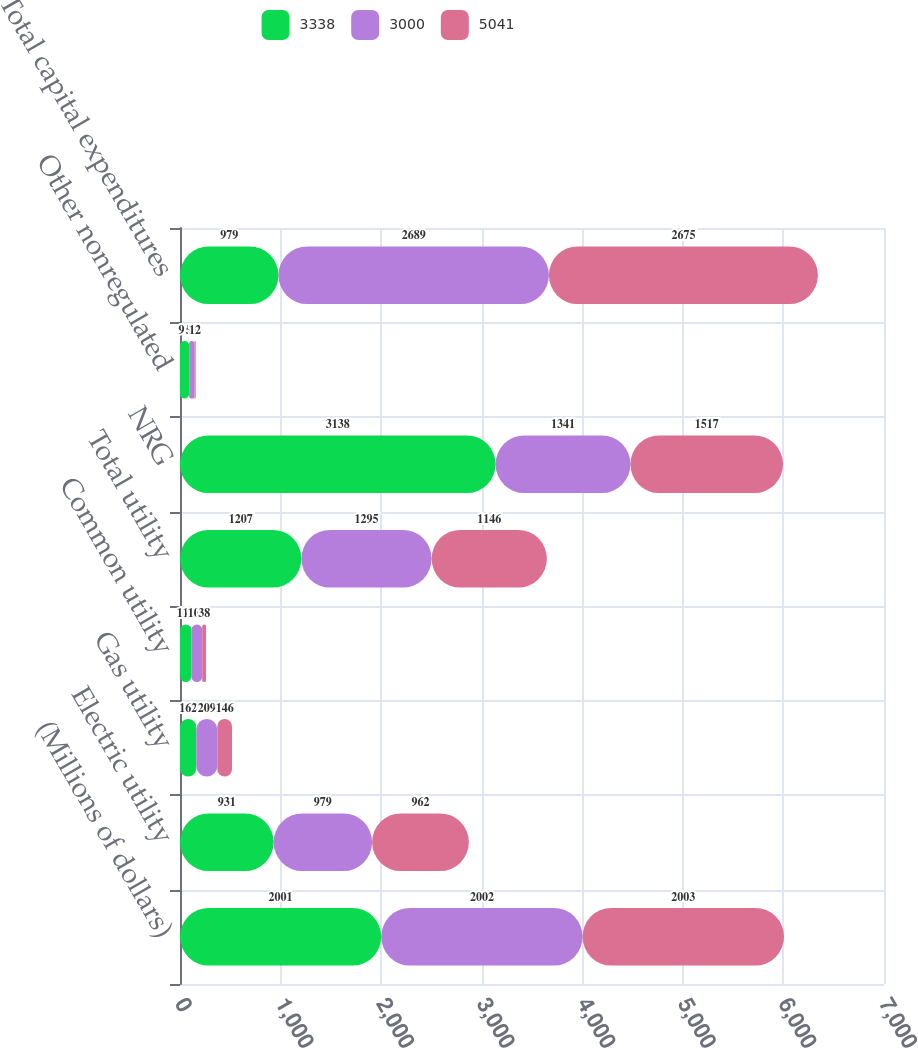Convert chart to OTSL. <chart><loc_0><loc_0><loc_500><loc_500><stacked_bar_chart><ecel><fcel>(Millions of dollars)<fcel>Electric utility<fcel>Gas utility<fcel>Common utility<fcel>Total utility<fcel>NRG<fcel>Other nonregulated<fcel>Total capital expenditures<nl><fcel>3338<fcel>2001<fcel>931<fcel>162<fcel>114<fcel>1207<fcel>3138<fcel>91<fcel>979<nl><fcel>3000<fcel>2002<fcel>979<fcel>209<fcel>107<fcel>1295<fcel>1341<fcel>53<fcel>2689<nl><fcel>5041<fcel>2003<fcel>962<fcel>146<fcel>38<fcel>1146<fcel>1517<fcel>12<fcel>2675<nl></chart> 